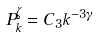Convert formula to latex. <formula><loc_0><loc_0><loc_500><loc_500>P ^ { \zeta } _ { k } = C _ { 3 } k ^ { - 3 \gamma }</formula> 